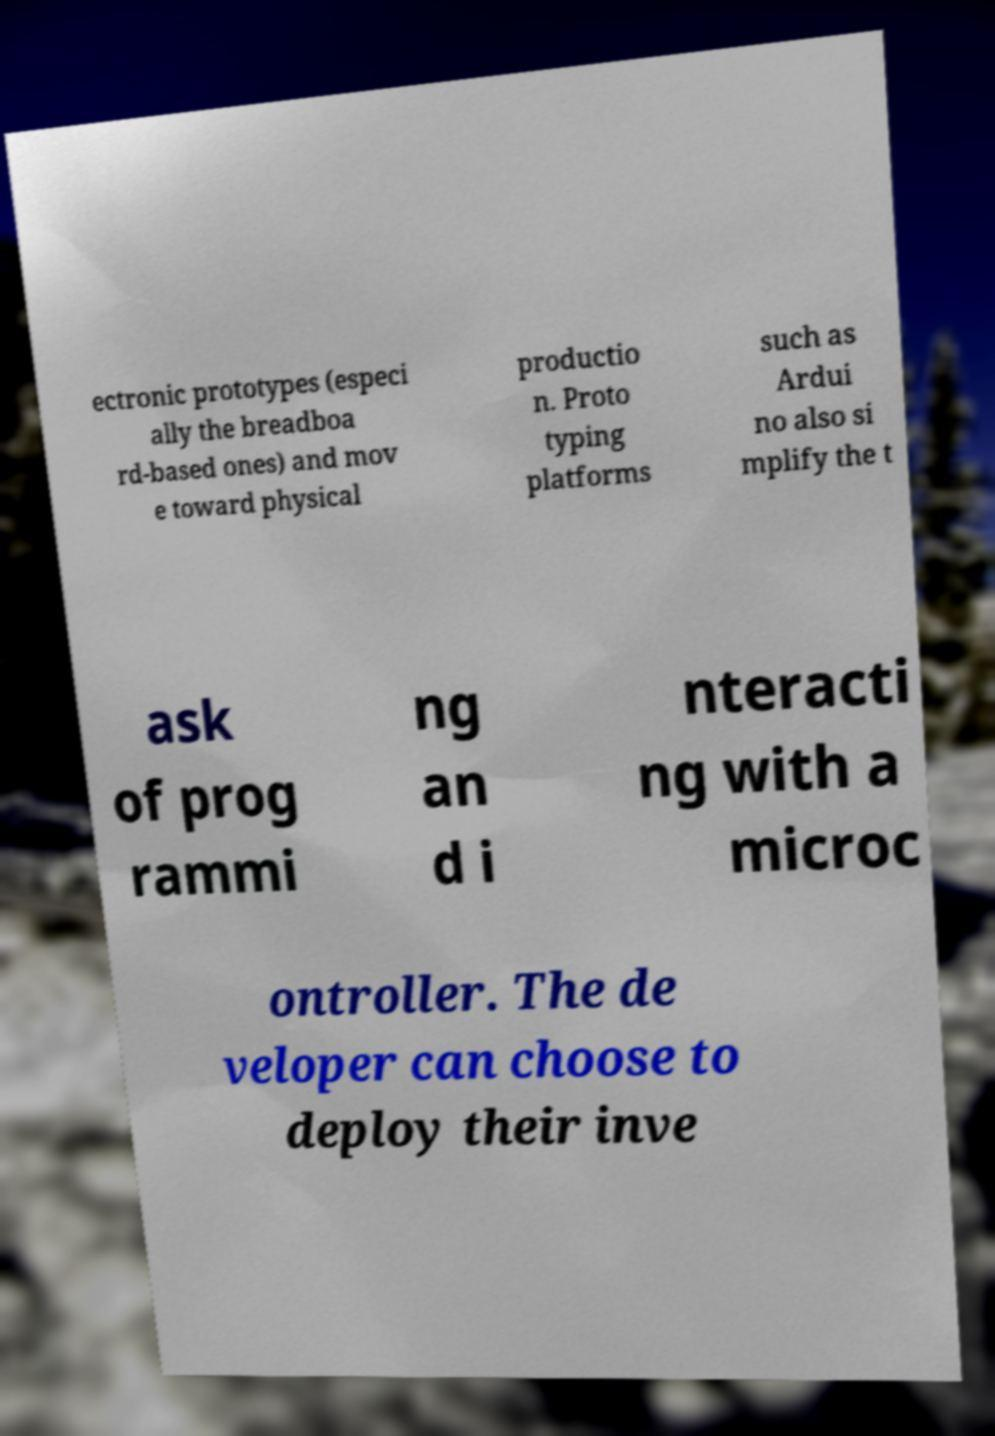Could you assist in decoding the text presented in this image and type it out clearly? ectronic prototypes (especi ally the breadboa rd-based ones) and mov e toward physical productio n. Proto typing platforms such as Ardui no also si mplify the t ask of prog rammi ng an d i nteracti ng with a microc ontroller. The de veloper can choose to deploy their inve 